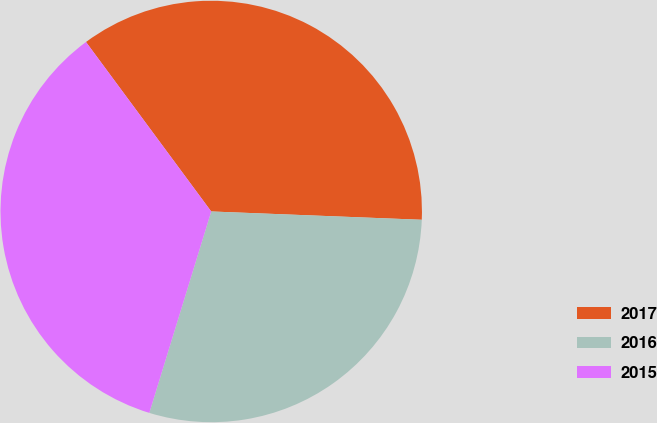Convert chart. <chart><loc_0><loc_0><loc_500><loc_500><pie_chart><fcel>2017<fcel>2016<fcel>2015<nl><fcel>35.76%<fcel>29.12%<fcel>35.13%<nl></chart> 